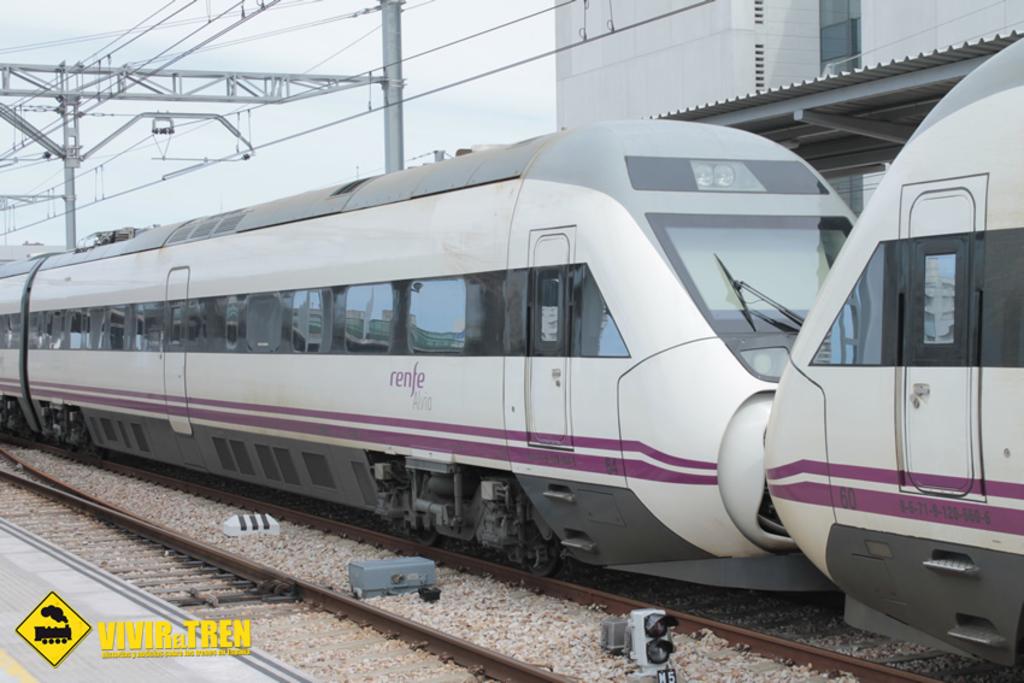What is the engine number of the engine on the right?
Make the answer very short. Unanswerable. 